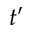<formula> <loc_0><loc_0><loc_500><loc_500>t ^ { \prime }</formula> 